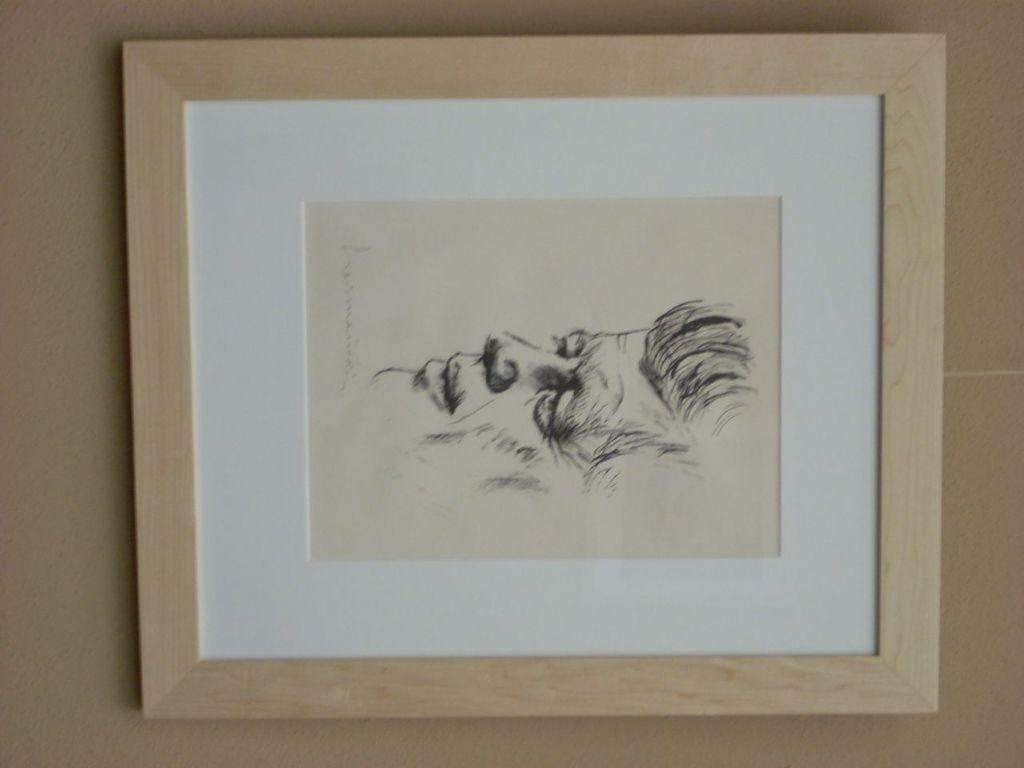What is hanging on the wall in the image? There is a frame on the wall. What is inside the frame? There is a painting inside the frame. What is the chance of winning the lottery in the image? There is no reference to a lottery or any chances in the image, so it's not possible to determine the odds of winning. 